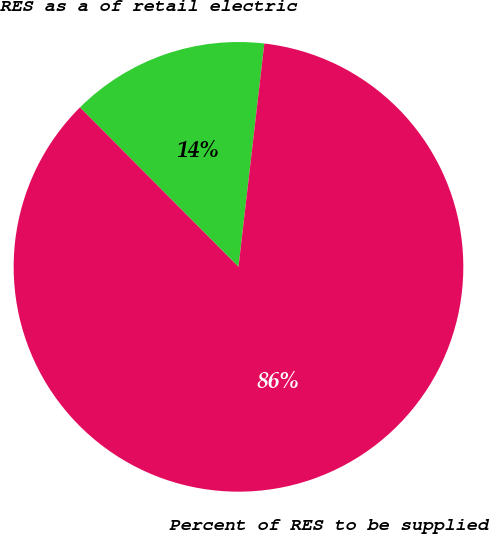Convert chart to OTSL. <chart><loc_0><loc_0><loc_500><loc_500><pie_chart><fcel>RES as a of retail electric<fcel>Percent of RES to be supplied<nl><fcel>14.29%<fcel>85.71%<nl></chart> 